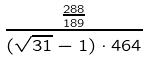Convert formula to latex. <formula><loc_0><loc_0><loc_500><loc_500>\frac { \frac { 2 8 8 } { 1 8 9 } } { ( \sqrt { 3 1 } - 1 ) \cdot 4 6 4 }</formula> 